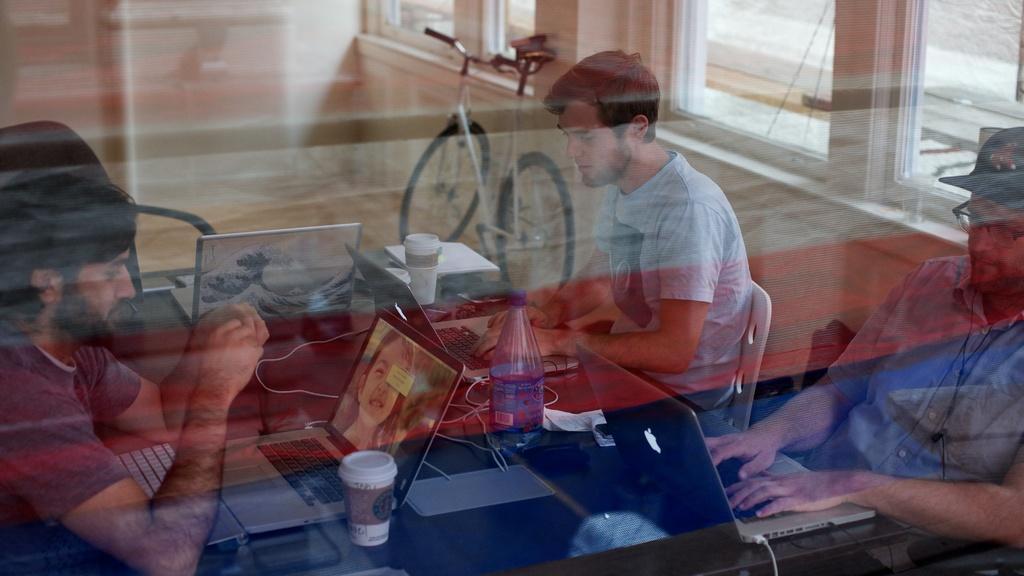Describe this image in one or two sentences. In this image there are three people sitting in front of the table. On the table there are laptops, bottles, cables and a few other objects, beside the table there is an empty chair. On the right side of the image there is a bicycle and a wall with windows. In the background there is a wall. 